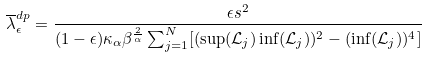<formula> <loc_0><loc_0><loc_500><loc_500>\overline { \lambda } _ { \epsilon } ^ { d p } = \frac { \epsilon s ^ { 2 } } { ( 1 - \epsilon ) \kappa _ { \alpha } \beta ^ { \frac { 2 } { \alpha } } \sum _ { j = 1 } ^ { N } [ ( \sup ( \mathcal { L } _ { j } ) \inf ( \mathcal { L } _ { j } ) ) ^ { 2 } - ( \inf ( \mathcal { L } _ { j } ) ) ^ { 4 } ] }</formula> 